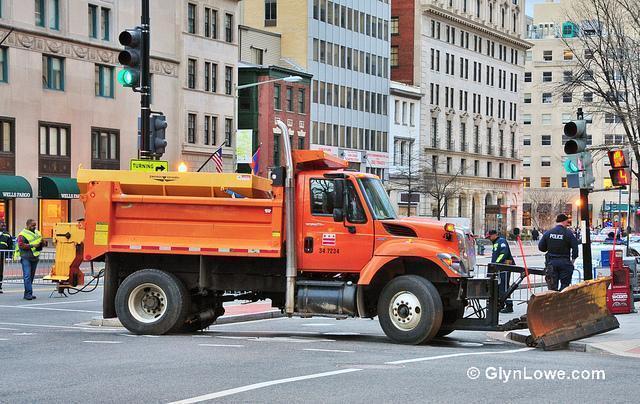Why is the man wearing a yellow vest?
Choose the right answer and clarify with the format: 'Answer: answer
Rationale: rationale.'
Options: Fashion, visibility, camouflage, costume. Answer: visibility.
Rationale: Yellow is very visible and as a construction worker he would want to be visible while being in the street 